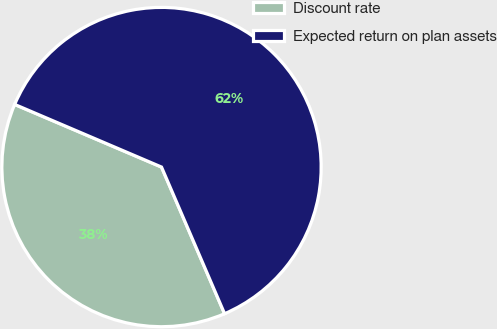<chart> <loc_0><loc_0><loc_500><loc_500><pie_chart><fcel>Discount rate<fcel>Expected return on plan assets<nl><fcel>37.88%<fcel>62.12%<nl></chart> 